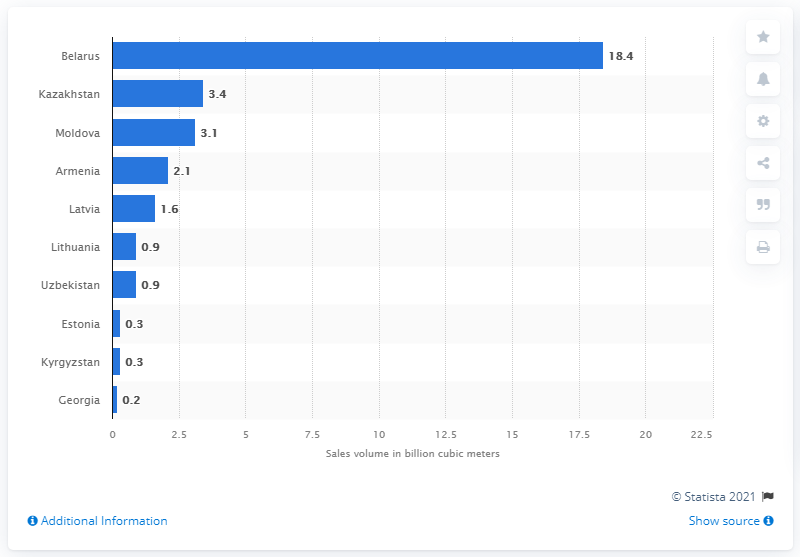Indicate a few pertinent items in this graphic. In 2020, Kazakhstan was the country that purchased the largest volume of natural gas from Gazprom, amounting to 3.4 billion cubic meters. In 2020, Gazprom, a Russian energy company, sold 18.4 billion cubic meters of natural gas to Belarus, a country in Eastern Europe. In 2020, Gazprom sold 18.4 cubic meters of natural gas to Belarus. 